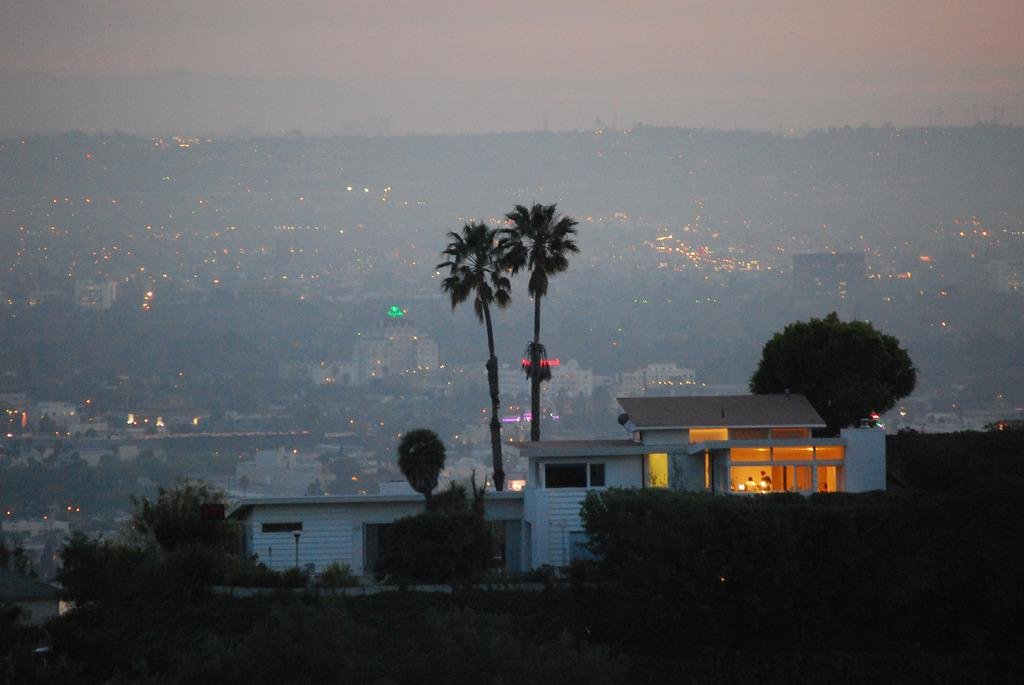What structure is located at the bottom of the image? There is a shed at the bottom of the image. What type of vegetation can be seen in the image? There are trees in the image. What can be seen in the background of the image? There are buildings, trees, lights, hills, and the sky visible in the background of the image. What time of day is it in the image, considering the presence of afternoon light? The provided facts do not mention the time of day or any specific lighting conditions, so it is not possible to determine the time of day from the image. Is there a water source visible in the image, such as a river or lake? There is no mention of a water source in the provided facts, so it is not possible to determine if there is a river or lake present in the image. 